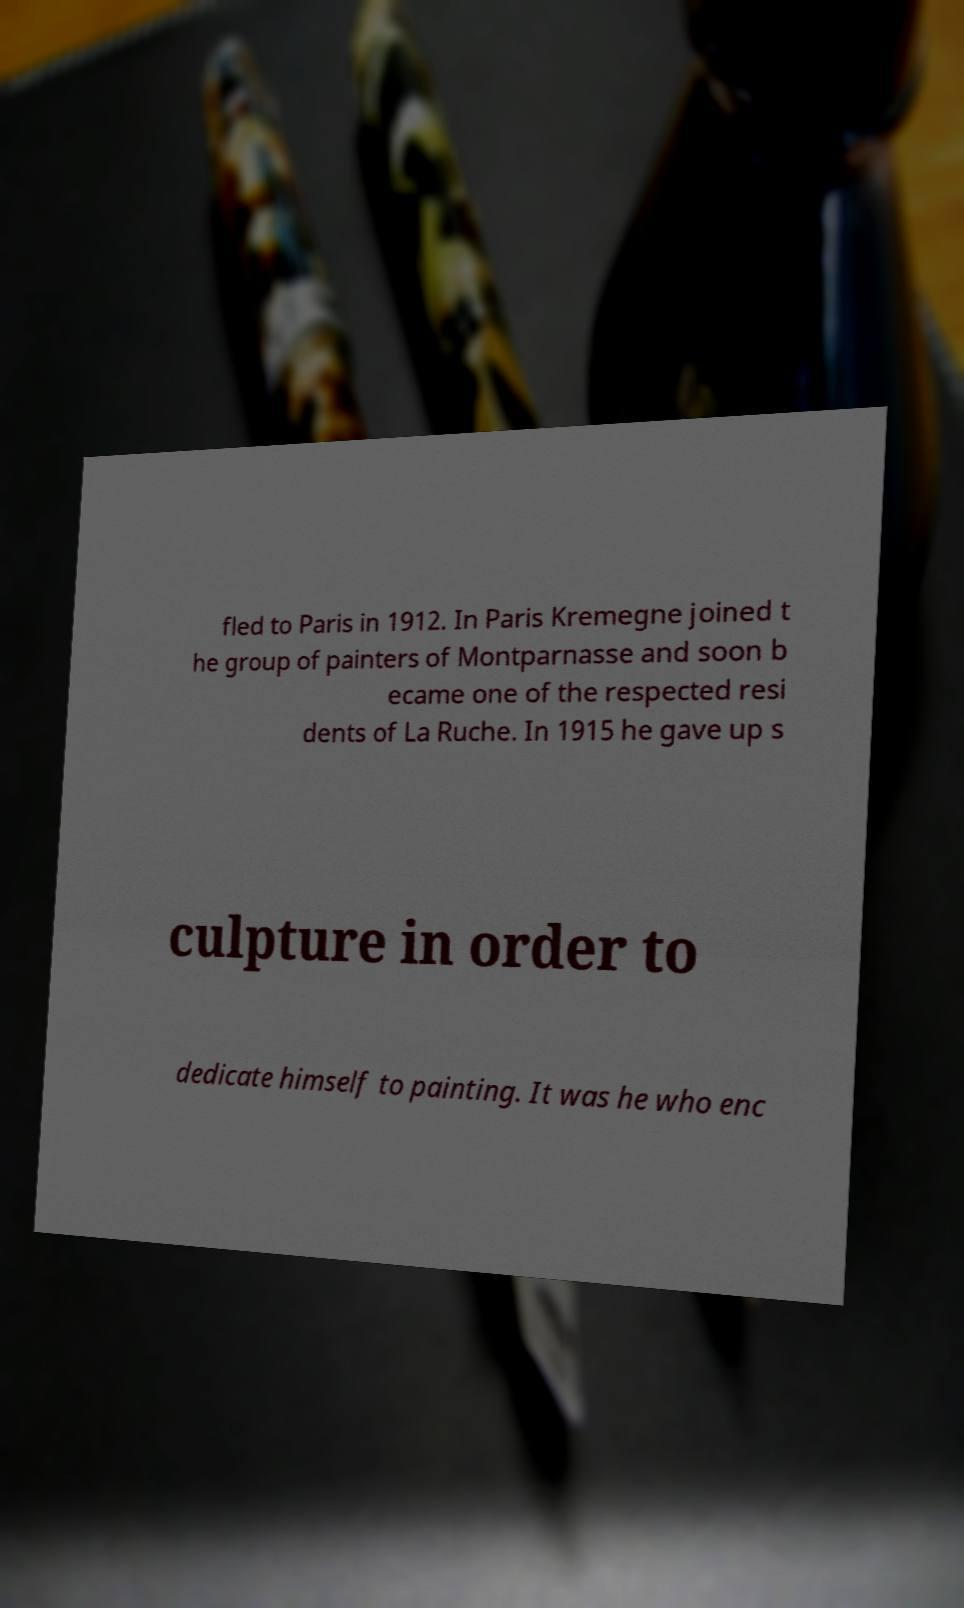Please read and relay the text visible in this image. What does it say? fled to Paris in 1912. In Paris Kremegne joined t he group of painters of Montparnasse and soon b ecame one of the respected resi dents of La Ruche. In 1915 he gave up s culpture in order to dedicate himself to painting. It was he who enc 